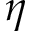Convert formula to latex. <formula><loc_0><loc_0><loc_500><loc_500>\eta</formula> 